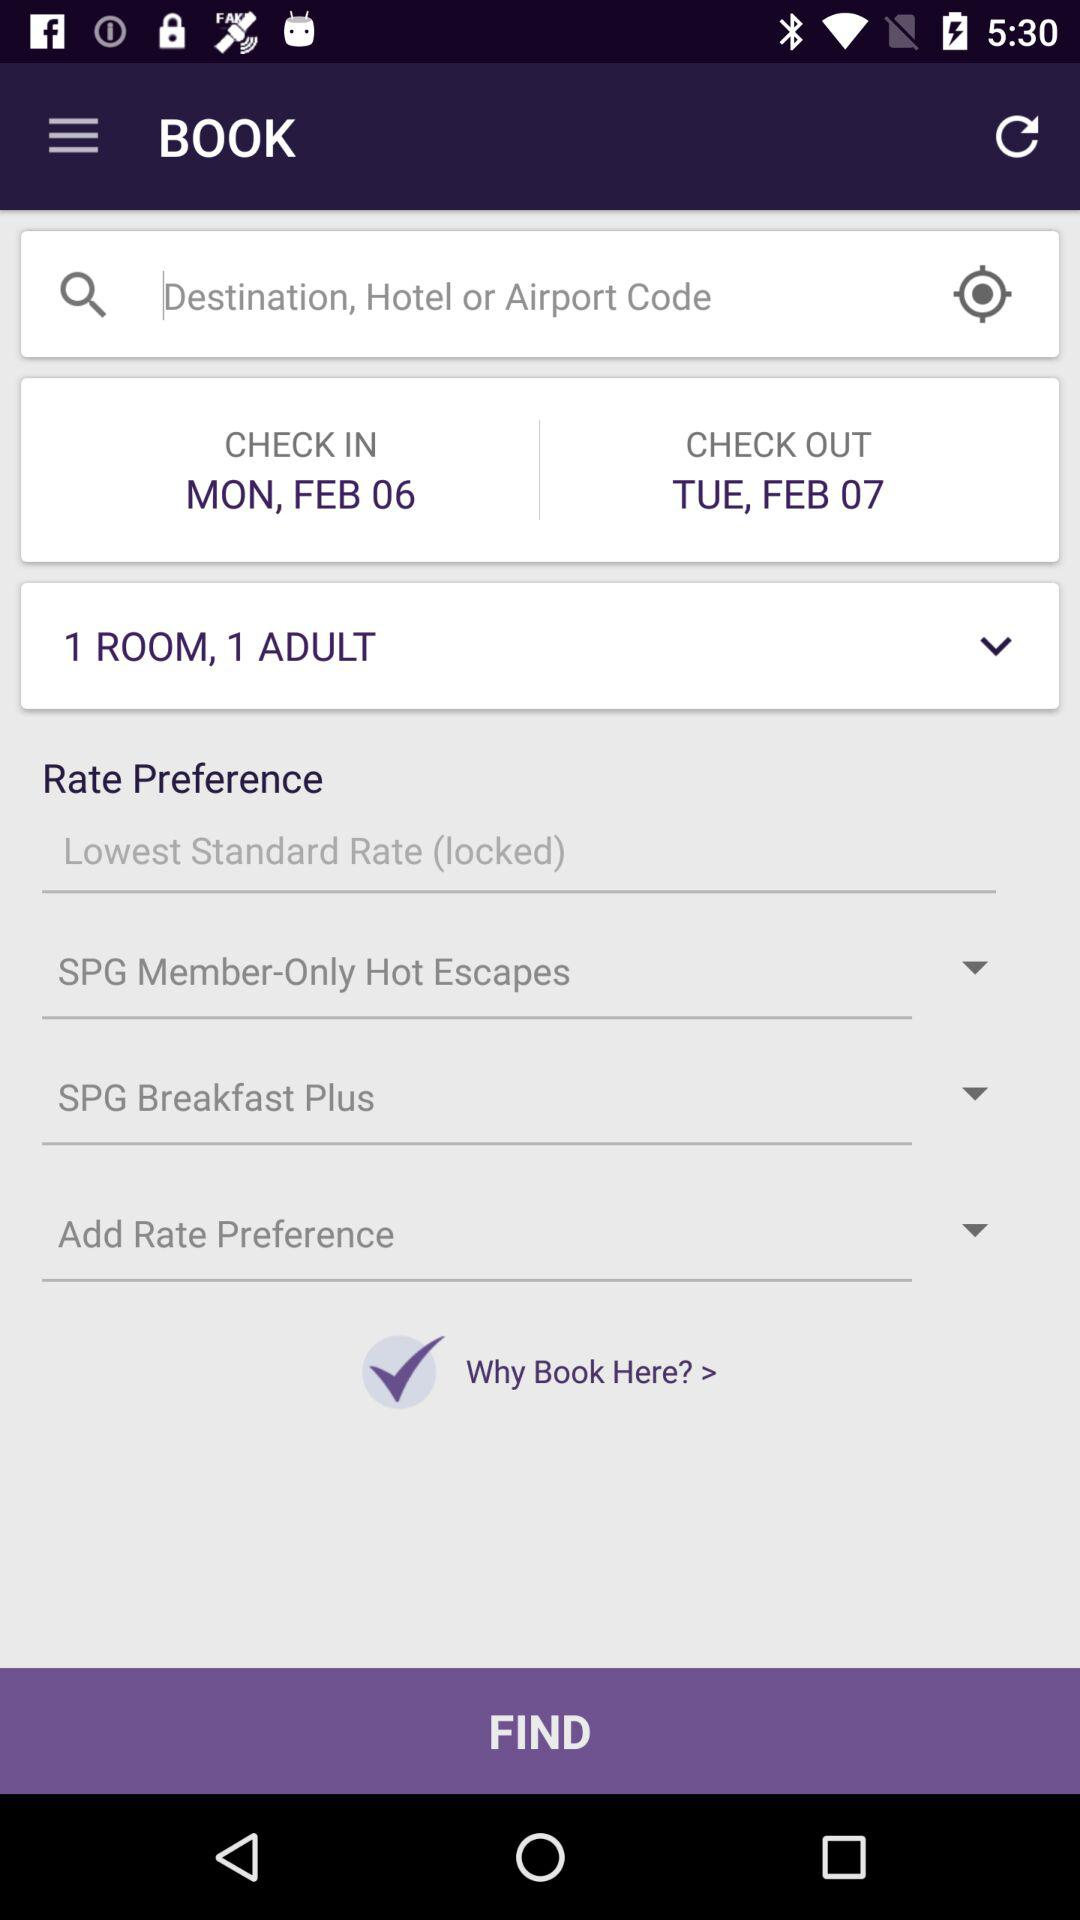What is the number of rooms? The number of rooms is 1. 